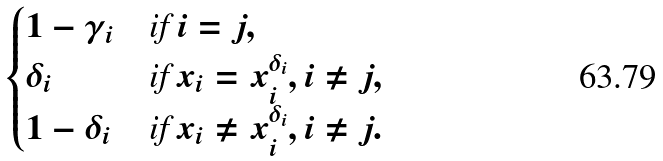Convert formula to latex. <formula><loc_0><loc_0><loc_500><loc_500>\begin{cases} 1 - \gamma _ { i } & \text {if } i = j , \\ \delta _ { i } & \text {if } x _ { i } = x _ { i } ^ { \delta _ { i } } , i \neq j , \\ 1 - \delta _ { i } & \text {if } x _ { i } \neq x _ { i } ^ { \delta _ { i } } , i \neq j . \end{cases}</formula> 